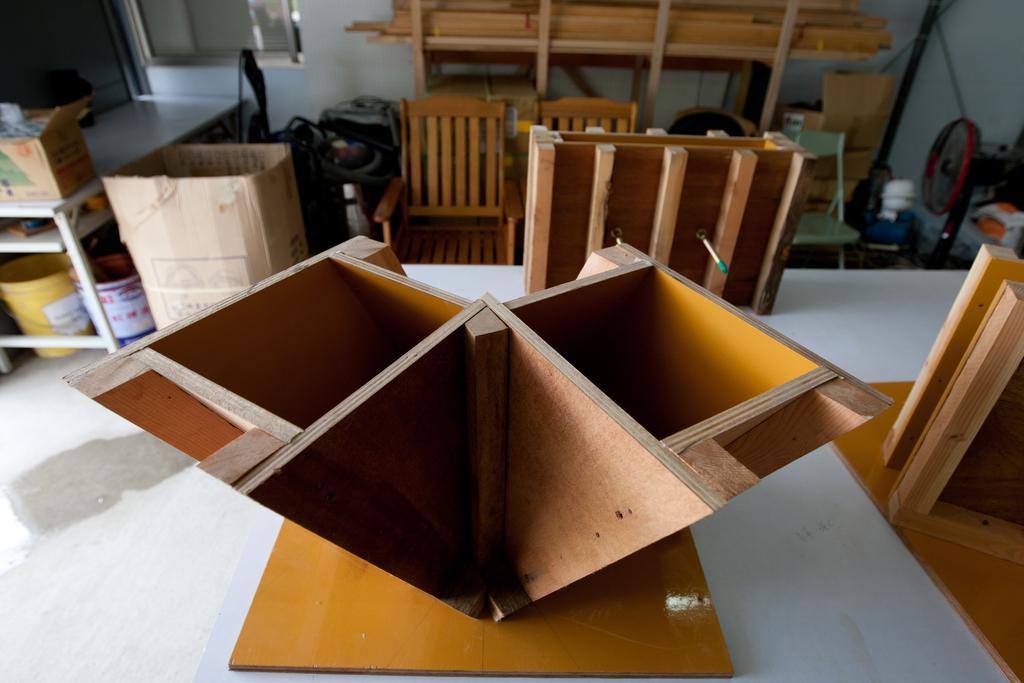In one or two sentences, can you explain what this image depicts? This is a picture taken in a room,on the table there are some wood items. Behind the wood items there are chairs, cardboard boxes, bucket, wood sticks and some items and a wall. 